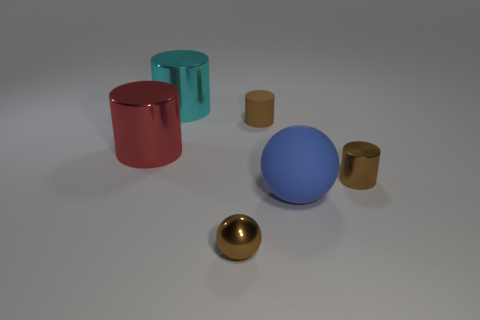Add 2 large cyan rubber objects. How many objects exist? 8 Subtract all cylinders. How many objects are left? 2 Subtract all brown metallic objects. Subtract all red things. How many objects are left? 3 Add 4 brown shiny cylinders. How many brown shiny cylinders are left? 5 Add 3 large cyan rubber cubes. How many large cyan rubber cubes exist? 3 Subtract 0 green cylinders. How many objects are left? 6 